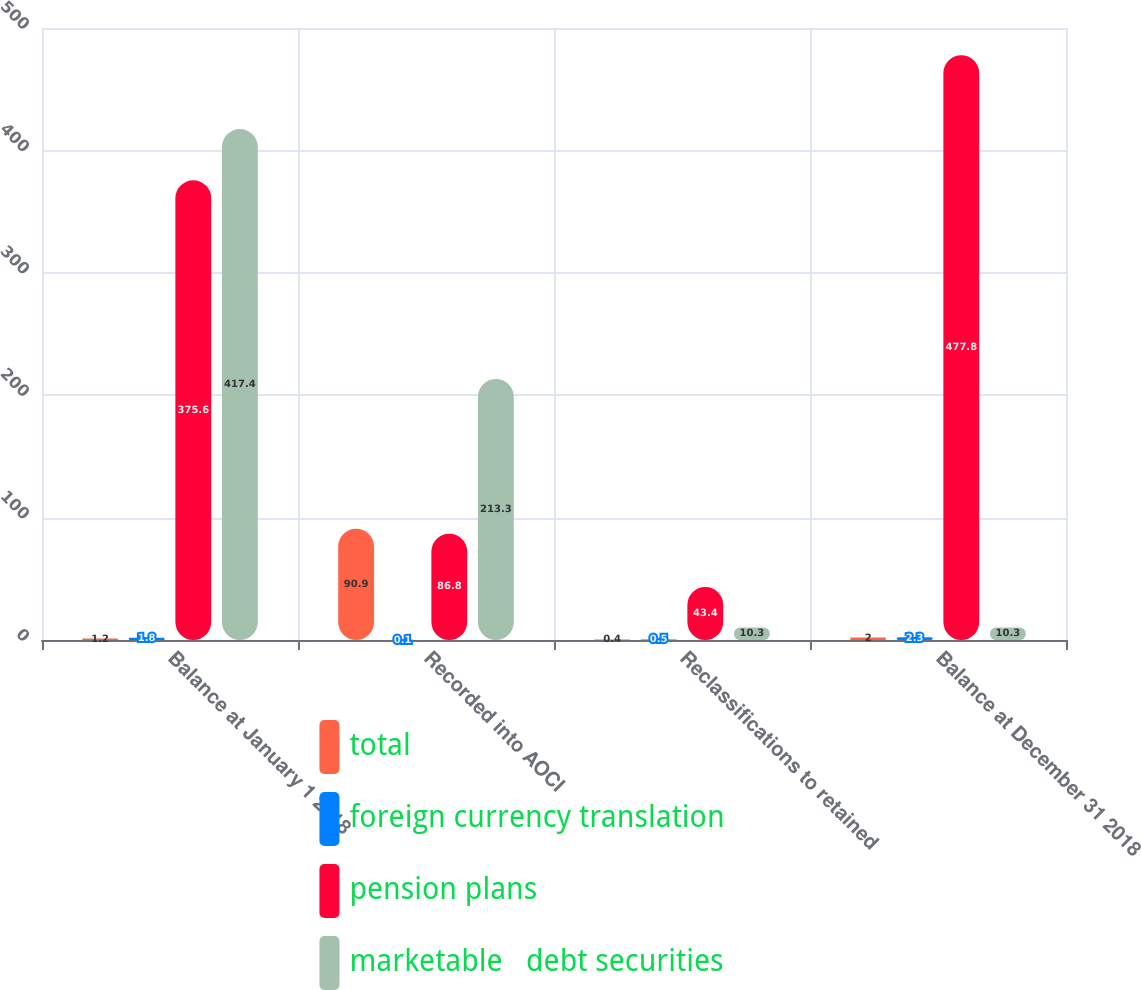Convert chart. <chart><loc_0><loc_0><loc_500><loc_500><stacked_bar_chart><ecel><fcel>Balance at January 1 2018<fcel>Recorded into AOCI<fcel>Reclassifications to retained<fcel>Balance at December 31 2018<nl><fcel>total<fcel>1.2<fcel>90.9<fcel>0.4<fcel>2<nl><fcel>foreign currency translation<fcel>1.8<fcel>0.1<fcel>0.5<fcel>2.3<nl><fcel>pension plans<fcel>375.6<fcel>86.8<fcel>43.4<fcel>477.8<nl><fcel>marketable   debt securities<fcel>417.4<fcel>213.3<fcel>10.3<fcel>10.3<nl></chart> 